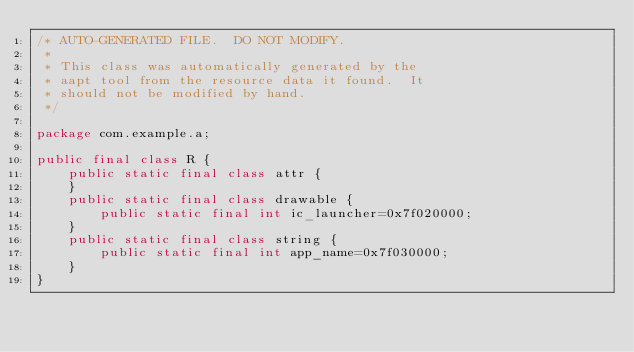Convert code to text. <code><loc_0><loc_0><loc_500><loc_500><_Java_>/* AUTO-GENERATED FILE.  DO NOT MODIFY.
 *
 * This class was automatically generated by the
 * aapt tool from the resource data it found.  It
 * should not be modified by hand.
 */

package com.example.a;

public final class R {
    public static final class attr {
    }
    public static final class drawable {
        public static final int ic_launcher=0x7f020000;
    }
    public static final class string {
        public static final int app_name=0x7f030000;
    }
}
</code> 